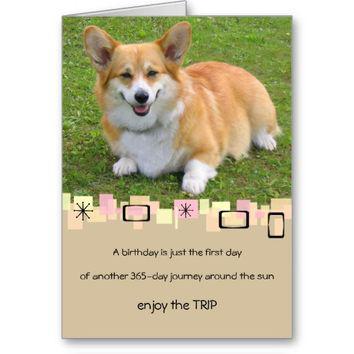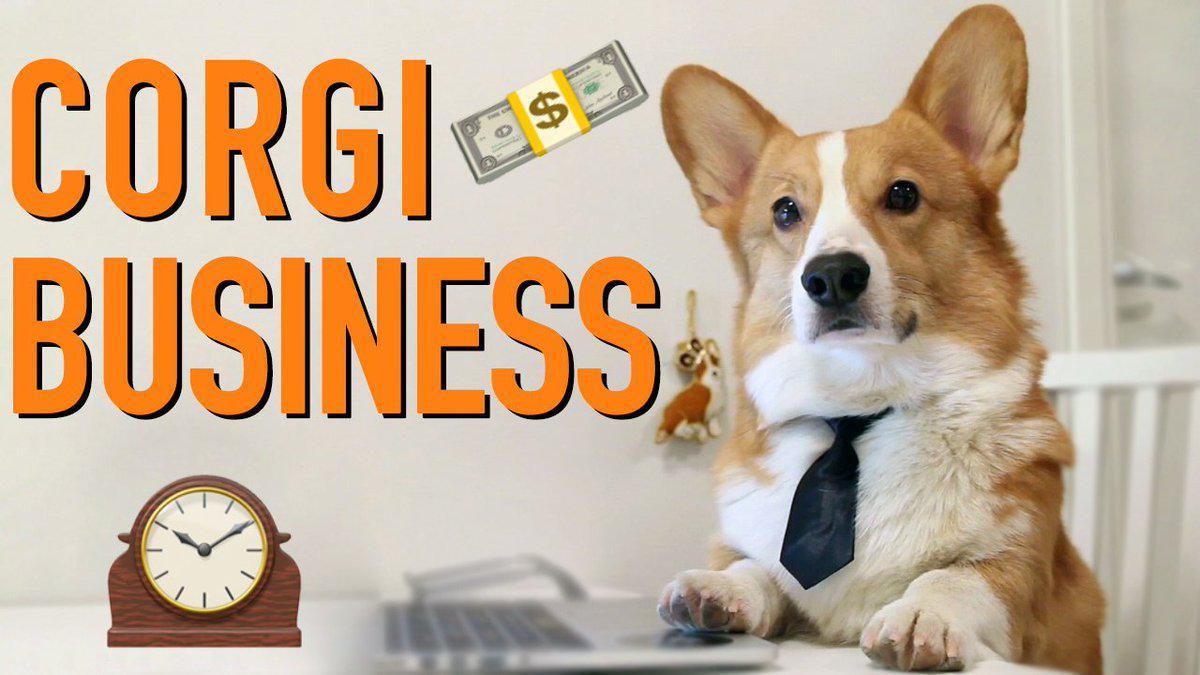The first image is the image on the left, the second image is the image on the right. Given the left and right images, does the statement "A corgi wearing a tie around his neck is behind a table with his front paws propped on its edge." hold true? Answer yes or no. Yes. 